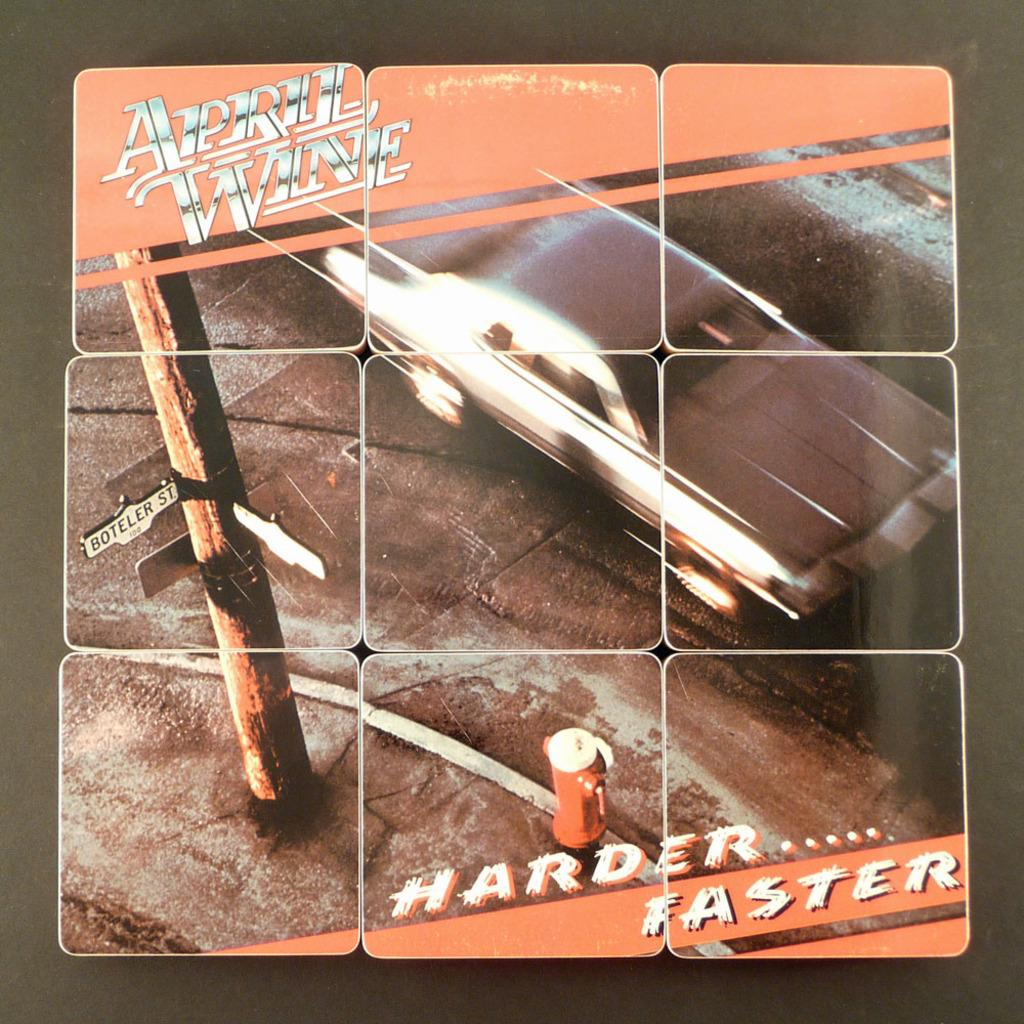Provide a one-sentence caption for the provided image. April Wine's album cover entitled Harder....Faster with a car on the front. 